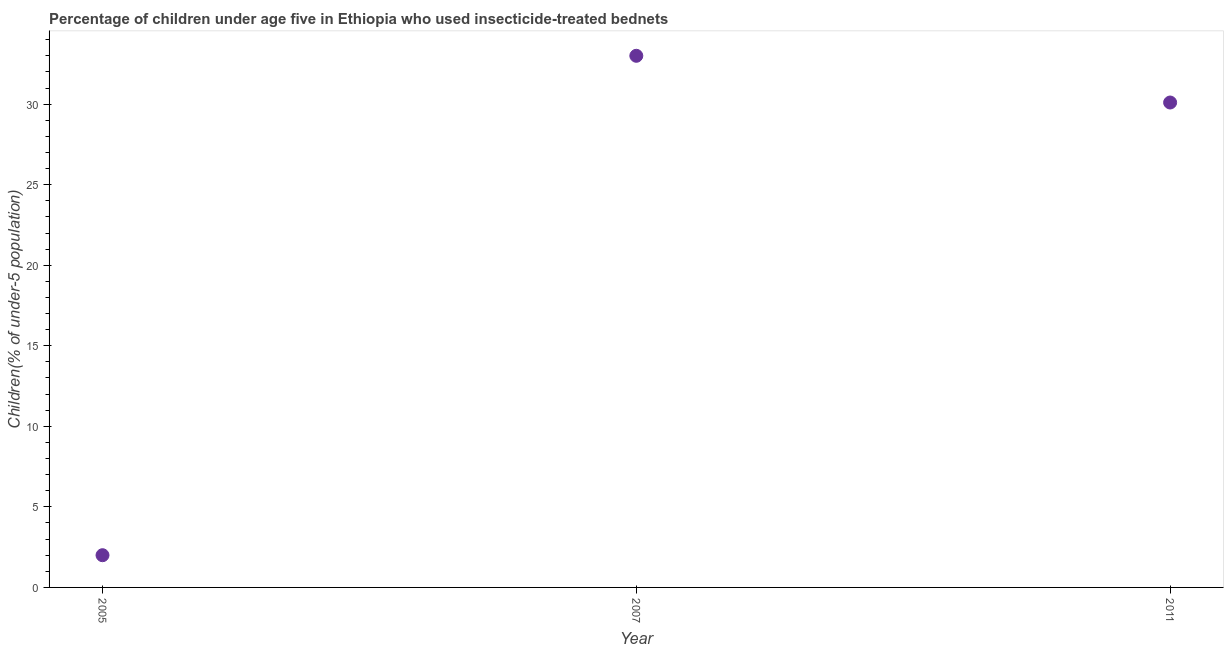What is the percentage of children who use of insecticide-treated bed nets in 2007?
Offer a terse response. 33. In which year was the percentage of children who use of insecticide-treated bed nets maximum?
Provide a succinct answer. 2007. What is the sum of the percentage of children who use of insecticide-treated bed nets?
Offer a very short reply. 65.1. What is the difference between the percentage of children who use of insecticide-treated bed nets in 2005 and 2007?
Give a very brief answer. -31. What is the average percentage of children who use of insecticide-treated bed nets per year?
Ensure brevity in your answer.  21.7. What is the median percentage of children who use of insecticide-treated bed nets?
Keep it short and to the point. 30.1. In how many years, is the percentage of children who use of insecticide-treated bed nets greater than 32 %?
Your response must be concise. 1. What is the ratio of the percentage of children who use of insecticide-treated bed nets in 2005 to that in 2007?
Ensure brevity in your answer.  0.06. Is the percentage of children who use of insecticide-treated bed nets in 2005 less than that in 2007?
Your answer should be compact. Yes. Is the difference between the percentage of children who use of insecticide-treated bed nets in 2005 and 2007 greater than the difference between any two years?
Offer a very short reply. Yes. What is the difference between the highest and the second highest percentage of children who use of insecticide-treated bed nets?
Your answer should be very brief. 2.9. In how many years, is the percentage of children who use of insecticide-treated bed nets greater than the average percentage of children who use of insecticide-treated bed nets taken over all years?
Offer a very short reply. 2. How many years are there in the graph?
Your answer should be compact. 3. What is the difference between two consecutive major ticks on the Y-axis?
Your answer should be very brief. 5. Are the values on the major ticks of Y-axis written in scientific E-notation?
Offer a very short reply. No. Does the graph contain any zero values?
Give a very brief answer. No. Does the graph contain grids?
Keep it short and to the point. No. What is the title of the graph?
Ensure brevity in your answer.  Percentage of children under age five in Ethiopia who used insecticide-treated bednets. What is the label or title of the X-axis?
Offer a very short reply. Year. What is the label or title of the Y-axis?
Your answer should be compact. Children(% of under-5 population). What is the Children(% of under-5 population) in 2005?
Keep it short and to the point. 2. What is the Children(% of under-5 population) in 2007?
Offer a very short reply. 33. What is the Children(% of under-5 population) in 2011?
Make the answer very short. 30.1. What is the difference between the Children(% of under-5 population) in 2005 and 2007?
Your response must be concise. -31. What is the difference between the Children(% of under-5 population) in 2005 and 2011?
Offer a terse response. -28.1. What is the ratio of the Children(% of under-5 population) in 2005 to that in 2007?
Your answer should be compact. 0.06. What is the ratio of the Children(% of under-5 population) in 2005 to that in 2011?
Offer a terse response. 0.07. What is the ratio of the Children(% of under-5 population) in 2007 to that in 2011?
Ensure brevity in your answer.  1.1. 